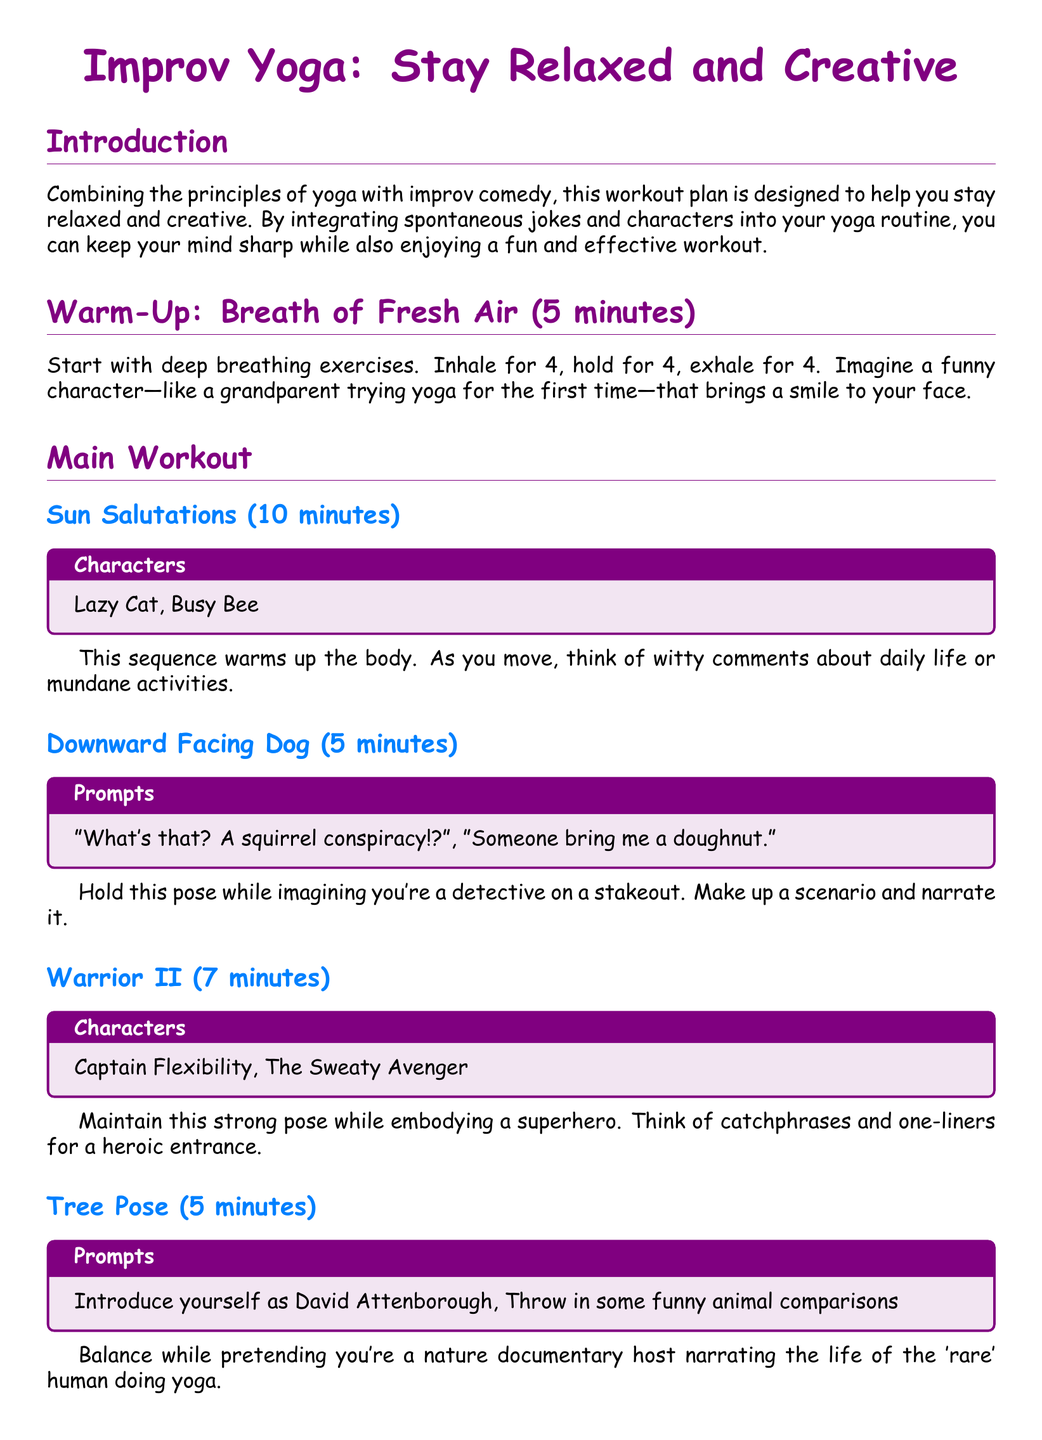What is the duration of the warm-up? The warm-up section specifies that it lasts for 5 minutes.
Answer: 5 minutes What character is associated with Downward Facing Dog? The document lists "detective" as the scenario imagined during this pose.
Answer: detective How long is the Sun Salutations section? The Sun Salutations section is stated to last for 10 minutes.
Answer: 10 minutes What is the purpose of the workout plan? The workout plan aims to combine yoga with improv comedy to enhance relaxation and creativity.
Answer: relaxation and creativity What is the final pose described in the workout? The last pose mentioned in the document is Savasana.
Answer: Savasana Name one character from the Warrior II section. The document lists "Captain Flexibility" as a character for this section.
Answer: Captain Flexibility How long should you hold Tree Pose? The Tree Pose section mentions that it should be held for 5 minutes.
Answer: 5 minutes What prompts are given for Tree Pose? The prompts for Tree Pose include "Introduce yourself as David Attenborough" and "Throw in some funny animal comparisons."
Answer: Introduce yourself as David Attenborough, Throw in some funny animal comparisons What is suggested as a humorous conclusion in Savasana? The conclusion suggests imagining being an entertaining talk show host and summarizing the workout humorously.
Answer: entertaining talk show host 